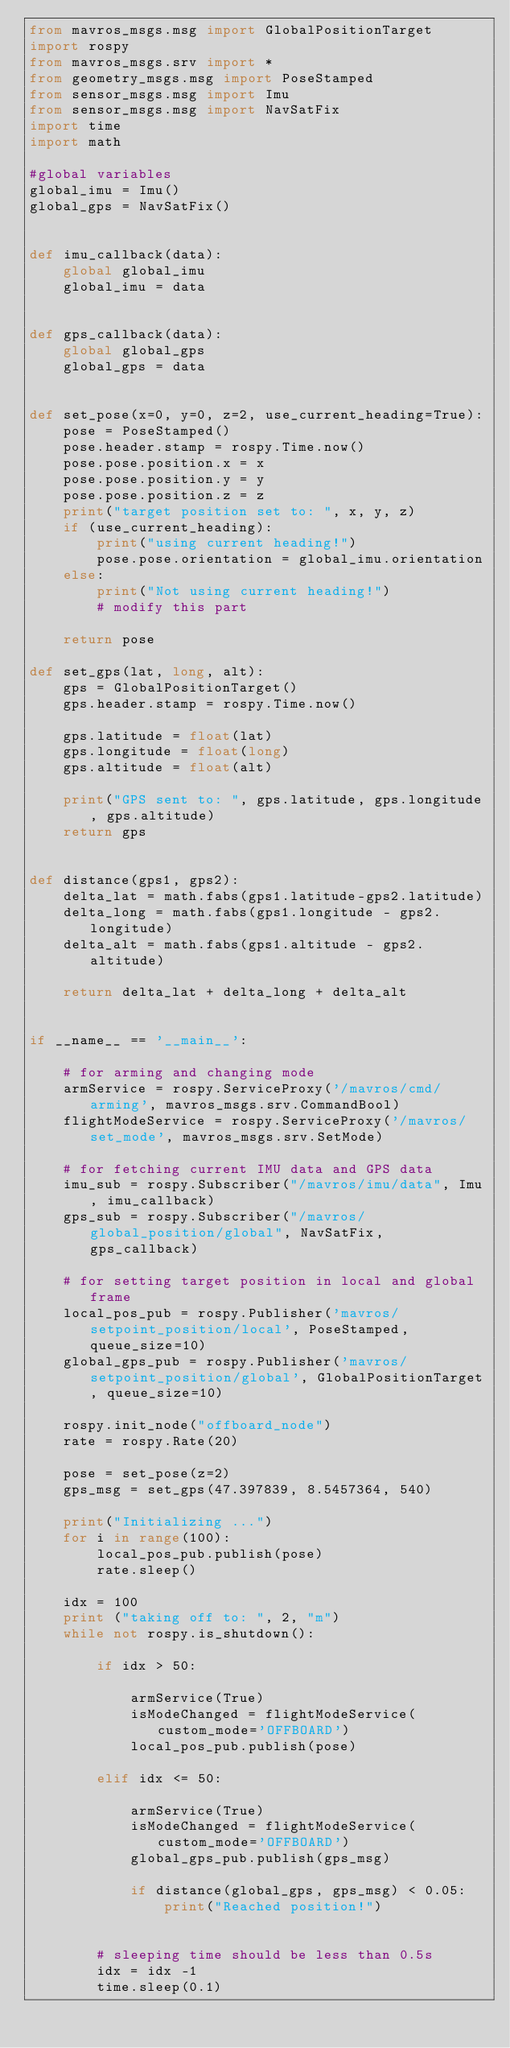<code> <loc_0><loc_0><loc_500><loc_500><_Python_>from mavros_msgs.msg import GlobalPositionTarget
import rospy
from mavros_msgs.srv import *
from geometry_msgs.msg import PoseStamped
from sensor_msgs.msg import Imu
from sensor_msgs.msg import NavSatFix
import time
import math

#global variables
global_imu = Imu()
global_gps = NavSatFix()


def imu_callback(data):
    global global_imu
    global_imu = data


def gps_callback(data):
    global global_gps
    global_gps = data


def set_pose(x=0, y=0, z=2, use_current_heading=True):
    pose = PoseStamped()
    pose.header.stamp = rospy.Time.now()
    pose.pose.position.x = x
    pose.pose.position.y = y
    pose.pose.position.z = z
    print("target position set to: ", x, y, z)
    if (use_current_heading):
        print("using current heading!")
        pose.pose.orientation = global_imu.orientation
    else:
        print("Not using current heading!")
        # modify this part

    return pose

def set_gps(lat, long, alt):
    gps = GlobalPositionTarget()
    gps.header.stamp = rospy.Time.now()

    gps.latitude = float(lat)
    gps.longitude = float(long)
    gps.altitude = float(alt)

    print("GPS sent to: ", gps.latitude, gps.longitude, gps.altitude)
    return gps


def distance(gps1, gps2):
    delta_lat = math.fabs(gps1.latitude-gps2.latitude)
    delta_long = math.fabs(gps1.longitude - gps2.longitude)
    delta_alt = math.fabs(gps1.altitude - gps2.altitude)

    return delta_lat + delta_long + delta_alt


if __name__ == '__main__':

    # for arming and changing mode
    armService = rospy.ServiceProxy('/mavros/cmd/arming', mavros_msgs.srv.CommandBool)
    flightModeService = rospy.ServiceProxy('/mavros/set_mode', mavros_msgs.srv.SetMode)

    # for fetching current IMU data and GPS data
    imu_sub = rospy.Subscriber("/mavros/imu/data", Imu, imu_callback)
    gps_sub = rospy.Subscriber("/mavros/global_position/global", NavSatFix, gps_callback)

    # for setting target position in local and global frame
    local_pos_pub = rospy.Publisher('mavros/setpoint_position/local', PoseStamped, queue_size=10)
    global_gps_pub = rospy.Publisher('mavros/setpoint_position/global', GlobalPositionTarget, queue_size=10)

    rospy.init_node("offboard_node")
    rate = rospy.Rate(20)

    pose = set_pose(z=2)
    gps_msg = set_gps(47.397839, 8.5457364, 540)

    print("Initializing ...")
    for i in range(100):
        local_pos_pub.publish(pose)
        rate.sleep()

    idx = 100
    print ("taking off to: ", 2, "m")
    while not rospy.is_shutdown():

        if idx > 50:

            armService(True)
            isModeChanged = flightModeService(custom_mode='OFFBOARD')
            local_pos_pub.publish(pose)

        elif idx <= 50:

            armService(True)
            isModeChanged = flightModeService(custom_mode='OFFBOARD')
            global_gps_pub.publish(gps_msg)

            if distance(global_gps, gps_msg) < 0.05:
                print("Reached position!")


        # sleeping time should be less than 0.5s
        idx = idx -1
        time.sleep(0.1)
</code> 